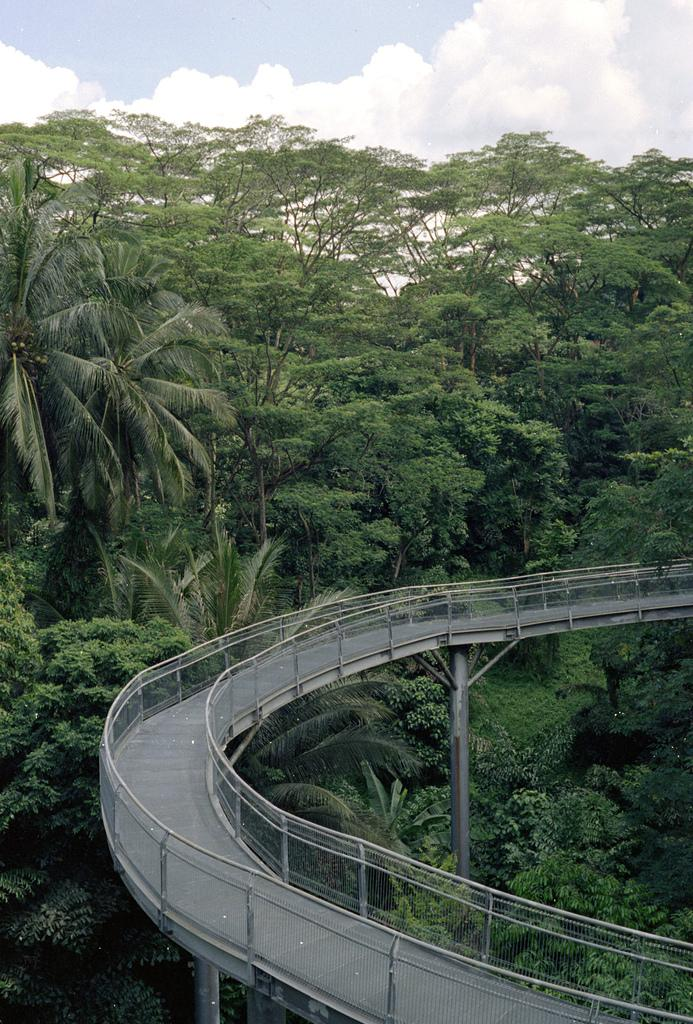What structure can be seen in the image? There is a bridge in the image. What type of vegetation is present in the image? There are trees in the image. What is visible in the background of the image? The sky with clouds is visible in the background of the image. What type of peace symbol can be seen on the stage in the image? There is no stage or peace symbol present in the image; it features a bridge and trees. 